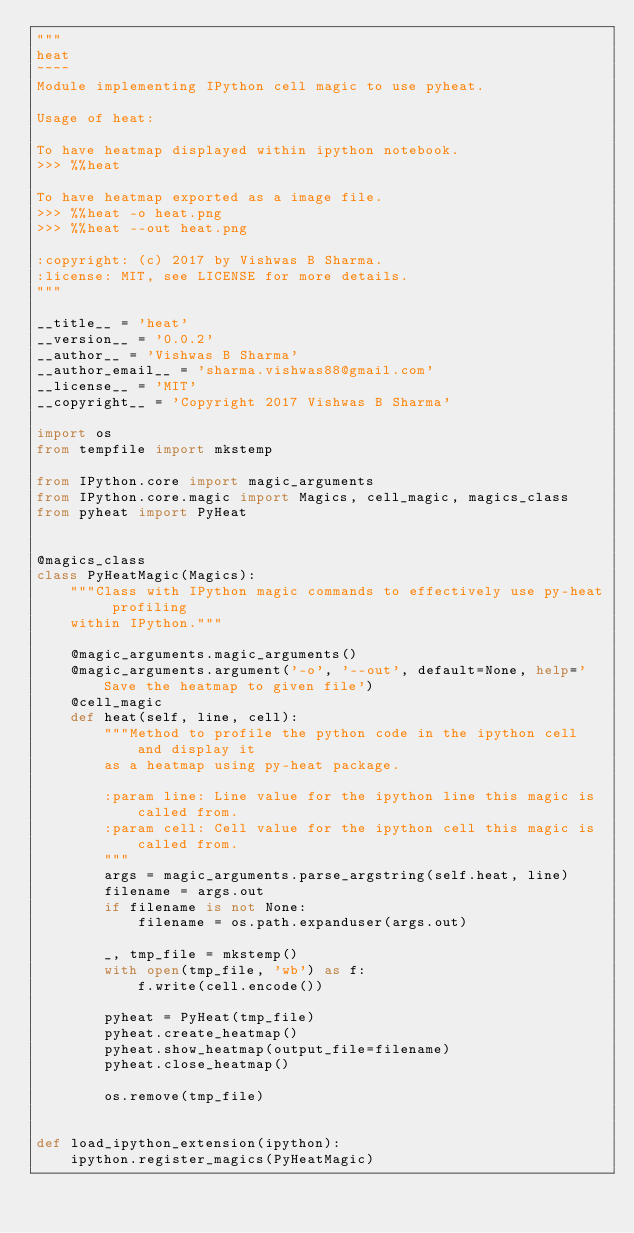<code> <loc_0><loc_0><loc_500><loc_500><_Python_>"""
heat
~~~~
Module implementing IPython cell magic to use pyheat.

Usage of heat:

To have heatmap displayed within ipython notebook.
>>> %%heat

To have heatmap exported as a image file.
>>> %%heat -o heat.png
>>> %%heat --out heat.png

:copyright: (c) 2017 by Vishwas B Sharma.
:license: MIT, see LICENSE for more details.
"""

__title__ = 'heat'
__version__ = '0.0.2'
__author__ = 'Vishwas B Sharma'
__author_email__ = 'sharma.vishwas88@gmail.com'
__license__ = 'MIT'
__copyright__ = 'Copyright 2017 Vishwas B Sharma'

import os
from tempfile import mkstemp

from IPython.core import magic_arguments
from IPython.core.magic import Magics, cell_magic, magics_class
from pyheat import PyHeat


@magics_class
class PyHeatMagic(Magics):
    """Class with IPython magic commands to effectively use py-heat profiling
    within IPython."""

    @magic_arguments.magic_arguments()
    @magic_arguments.argument('-o', '--out', default=None, help='Save the heatmap to given file')
    @cell_magic
    def heat(self, line, cell):
        """Method to profile the python code in the ipython cell and display it
        as a heatmap using py-heat package.

        :param line: Line value for the ipython line this magic is called from.
        :param cell: Cell value for the ipython cell this magic is called from.
        """
        args = magic_arguments.parse_argstring(self.heat, line)
        filename = args.out
        if filename is not None:
            filename = os.path.expanduser(args.out)

        _, tmp_file = mkstemp()
        with open(tmp_file, 'wb') as f:
            f.write(cell.encode())

        pyheat = PyHeat(tmp_file)
        pyheat.create_heatmap()
        pyheat.show_heatmap(output_file=filename)
        pyheat.close_heatmap()

        os.remove(tmp_file)


def load_ipython_extension(ipython):
    ipython.register_magics(PyHeatMagic)
</code> 